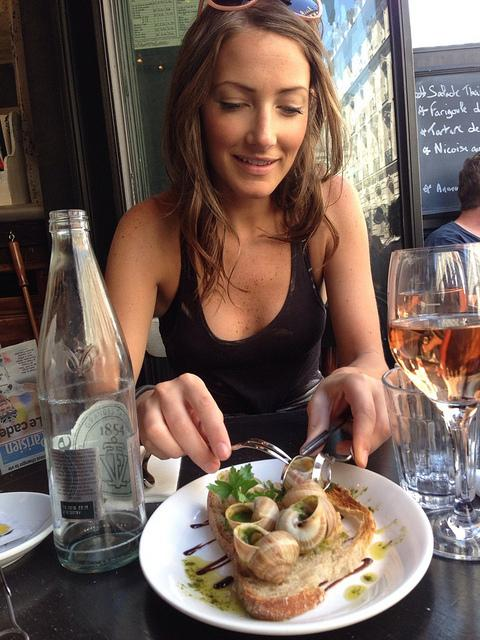What country are they in? france 